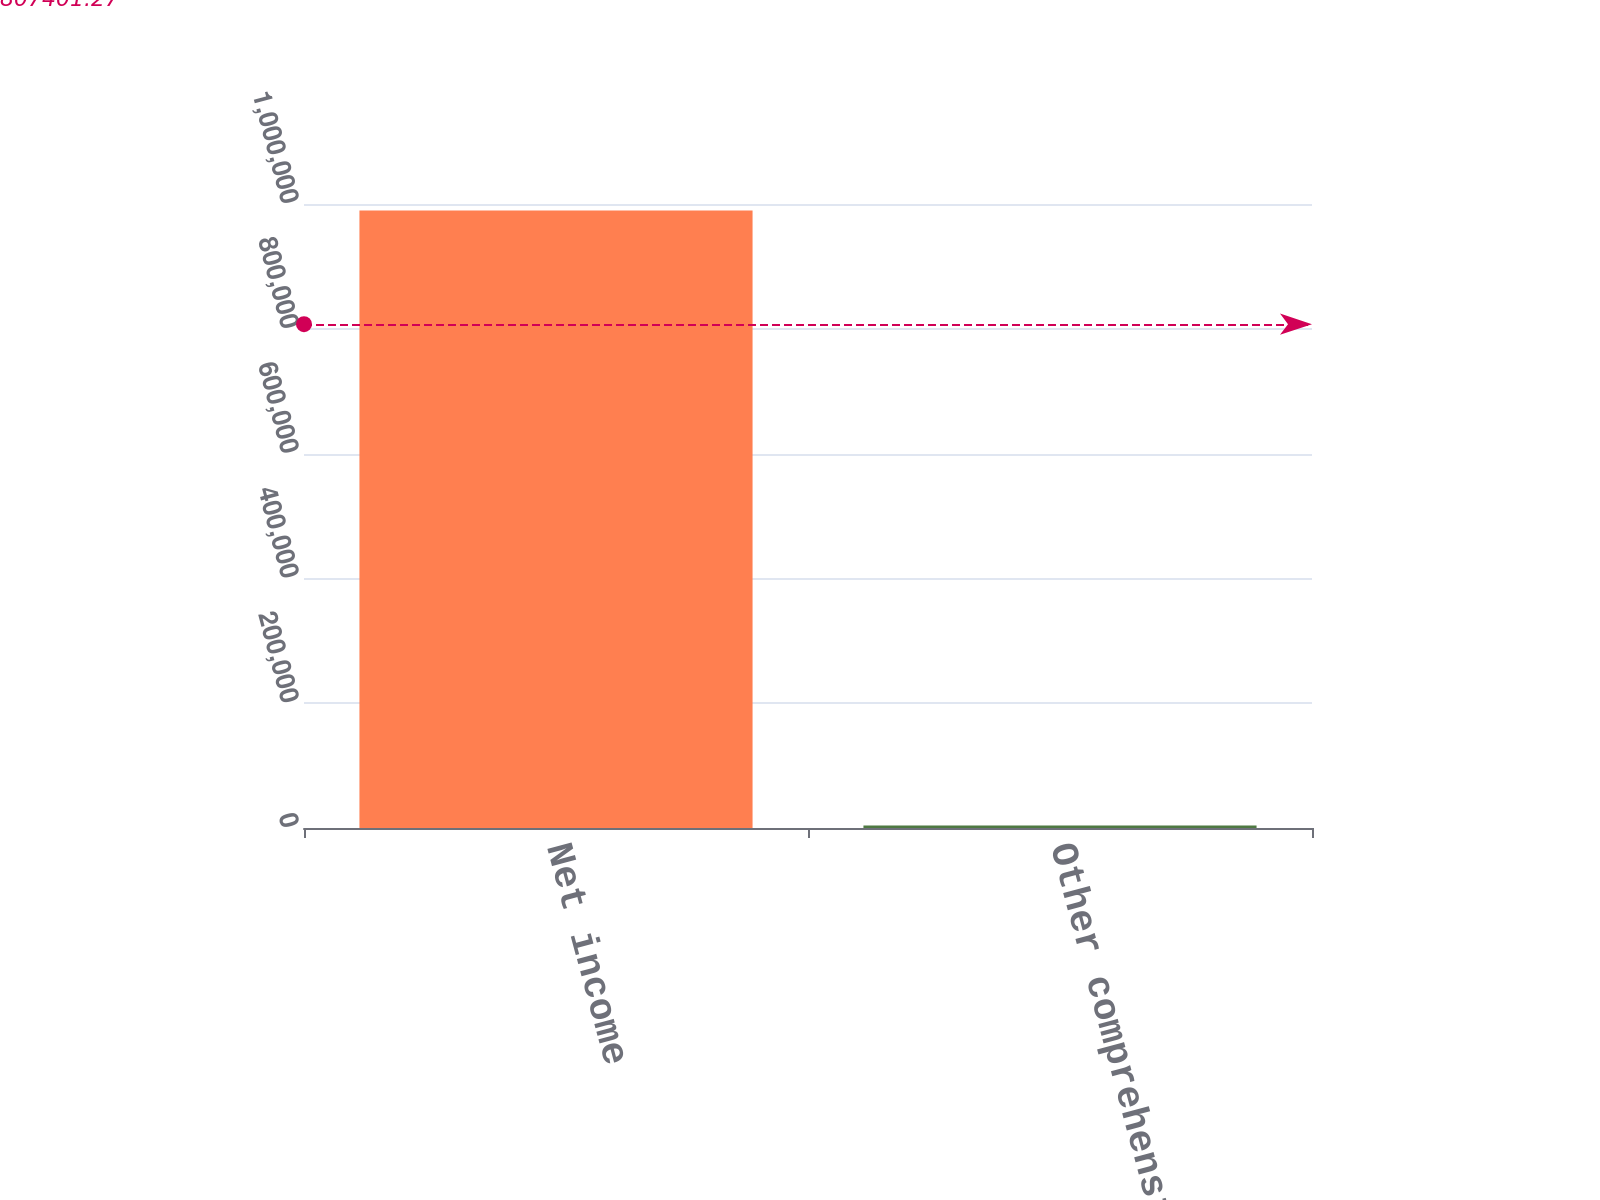Convert chart to OTSL. <chart><loc_0><loc_0><loc_500><loc_500><bar_chart><fcel>Net income<fcel>Other comprehensive (loss)<nl><fcel>989622<fcel>3826<nl></chart> 